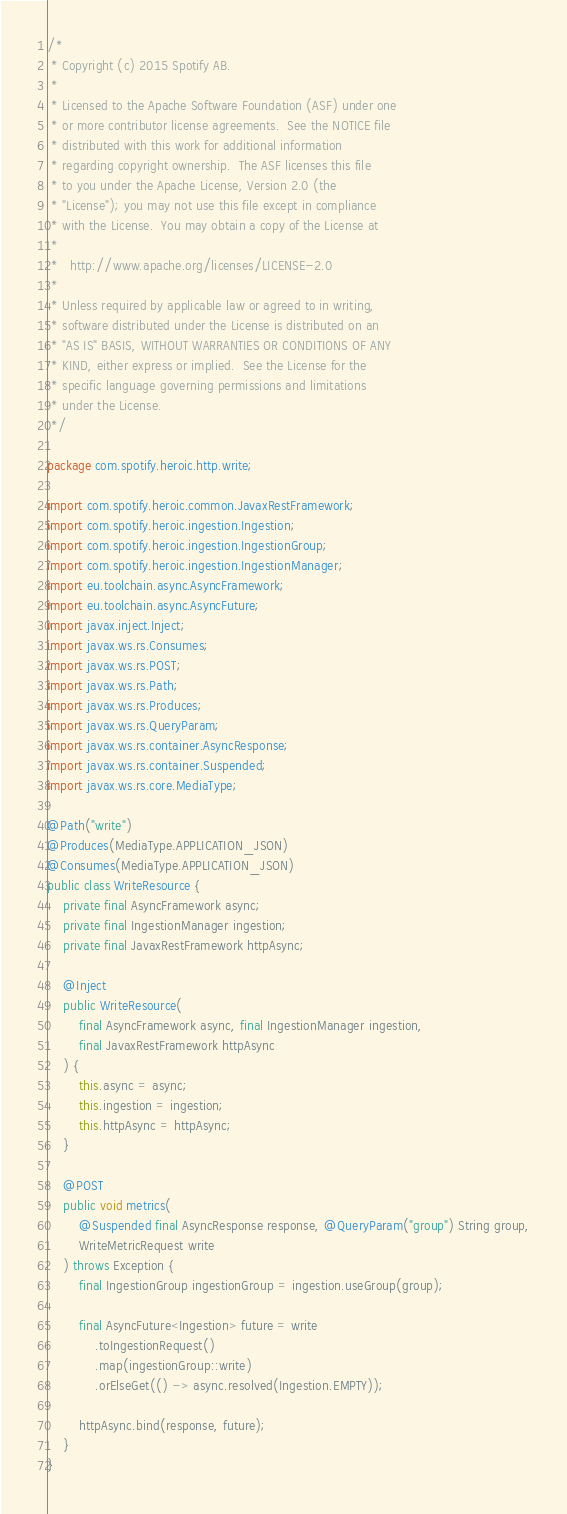<code> <loc_0><loc_0><loc_500><loc_500><_Java_>/*
 * Copyright (c) 2015 Spotify AB.
 *
 * Licensed to the Apache Software Foundation (ASF) under one
 * or more contributor license agreements.  See the NOTICE file
 * distributed with this work for additional information
 * regarding copyright ownership.  The ASF licenses this file
 * to you under the Apache License, Version 2.0 (the
 * "License"); you may not use this file except in compliance
 * with the License.  You may obtain a copy of the License at
 *
 *   http://www.apache.org/licenses/LICENSE-2.0
 *
 * Unless required by applicable law or agreed to in writing,
 * software distributed under the License is distributed on an
 * "AS IS" BASIS, WITHOUT WARRANTIES OR CONDITIONS OF ANY
 * KIND, either express or implied.  See the License for the
 * specific language governing permissions and limitations
 * under the License.
 */

package com.spotify.heroic.http.write;

import com.spotify.heroic.common.JavaxRestFramework;
import com.spotify.heroic.ingestion.Ingestion;
import com.spotify.heroic.ingestion.IngestionGroup;
import com.spotify.heroic.ingestion.IngestionManager;
import eu.toolchain.async.AsyncFramework;
import eu.toolchain.async.AsyncFuture;
import javax.inject.Inject;
import javax.ws.rs.Consumes;
import javax.ws.rs.POST;
import javax.ws.rs.Path;
import javax.ws.rs.Produces;
import javax.ws.rs.QueryParam;
import javax.ws.rs.container.AsyncResponse;
import javax.ws.rs.container.Suspended;
import javax.ws.rs.core.MediaType;

@Path("write")
@Produces(MediaType.APPLICATION_JSON)
@Consumes(MediaType.APPLICATION_JSON)
public class WriteResource {
    private final AsyncFramework async;
    private final IngestionManager ingestion;
    private final JavaxRestFramework httpAsync;

    @Inject
    public WriteResource(
        final AsyncFramework async, final IngestionManager ingestion,
        final JavaxRestFramework httpAsync
    ) {
        this.async = async;
        this.ingestion = ingestion;
        this.httpAsync = httpAsync;
    }

    @POST
    public void metrics(
        @Suspended final AsyncResponse response, @QueryParam("group") String group,
        WriteMetricRequest write
    ) throws Exception {
        final IngestionGroup ingestionGroup = ingestion.useGroup(group);

        final AsyncFuture<Ingestion> future = write
            .toIngestionRequest()
            .map(ingestionGroup::write)
            .orElseGet(() -> async.resolved(Ingestion.EMPTY));

        httpAsync.bind(response, future);
    }
}
</code> 